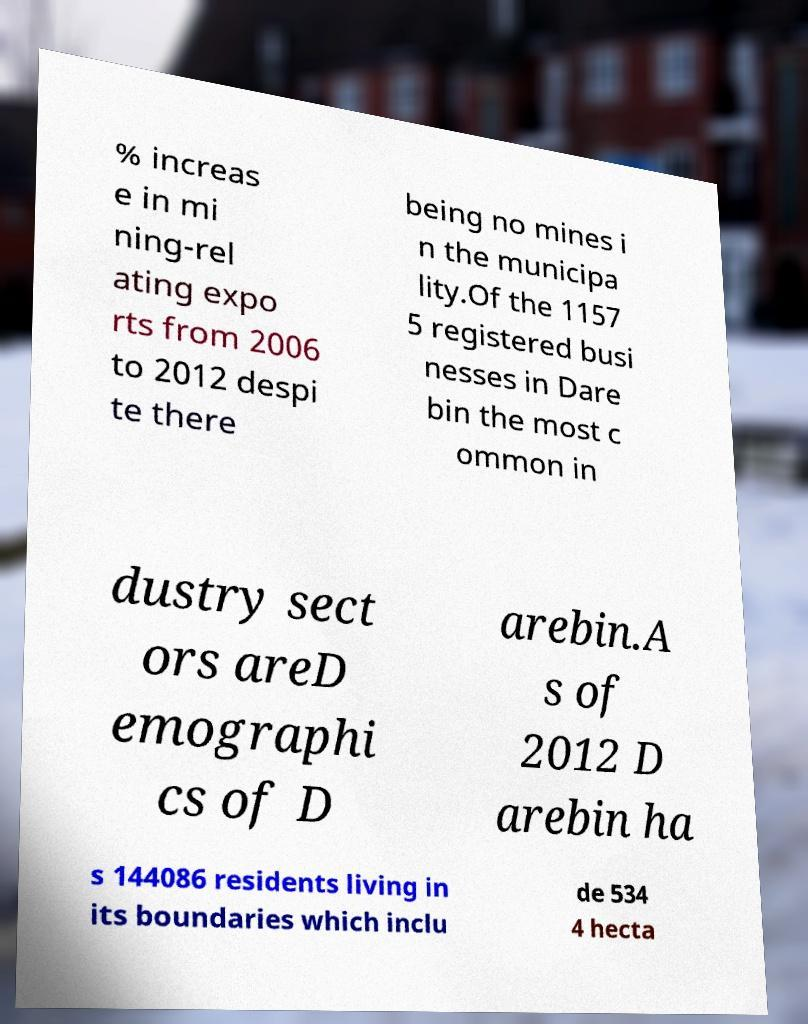Can you accurately transcribe the text from the provided image for me? % increas e in mi ning-rel ating expo rts from 2006 to 2012 despi te there being no mines i n the municipa lity.Of the 1157 5 registered busi nesses in Dare bin the most c ommon in dustry sect ors areD emographi cs of D arebin.A s of 2012 D arebin ha s 144086 residents living in its boundaries which inclu de 534 4 hecta 